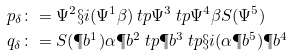Convert formula to latex. <formula><loc_0><loc_0><loc_500><loc_500>p _ { \delta } & \colon = \Psi ^ { 2 } \S i ( \Psi ^ { 1 } \beta ) \ t p \Psi ^ { 3 } \ t p \Psi ^ { 4 } \beta S ( \Psi ^ { 5 } ) \\ q _ { \delta } & \colon = S ( \P b ^ { 1 } ) \alpha \P b ^ { 2 } \ t p \P b ^ { 3 } \ t p \S i ( \alpha \P b ^ { 5 } ) \P b ^ { 4 }</formula> 